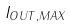<formula> <loc_0><loc_0><loc_500><loc_500>I _ { O U T , M A X }</formula> 